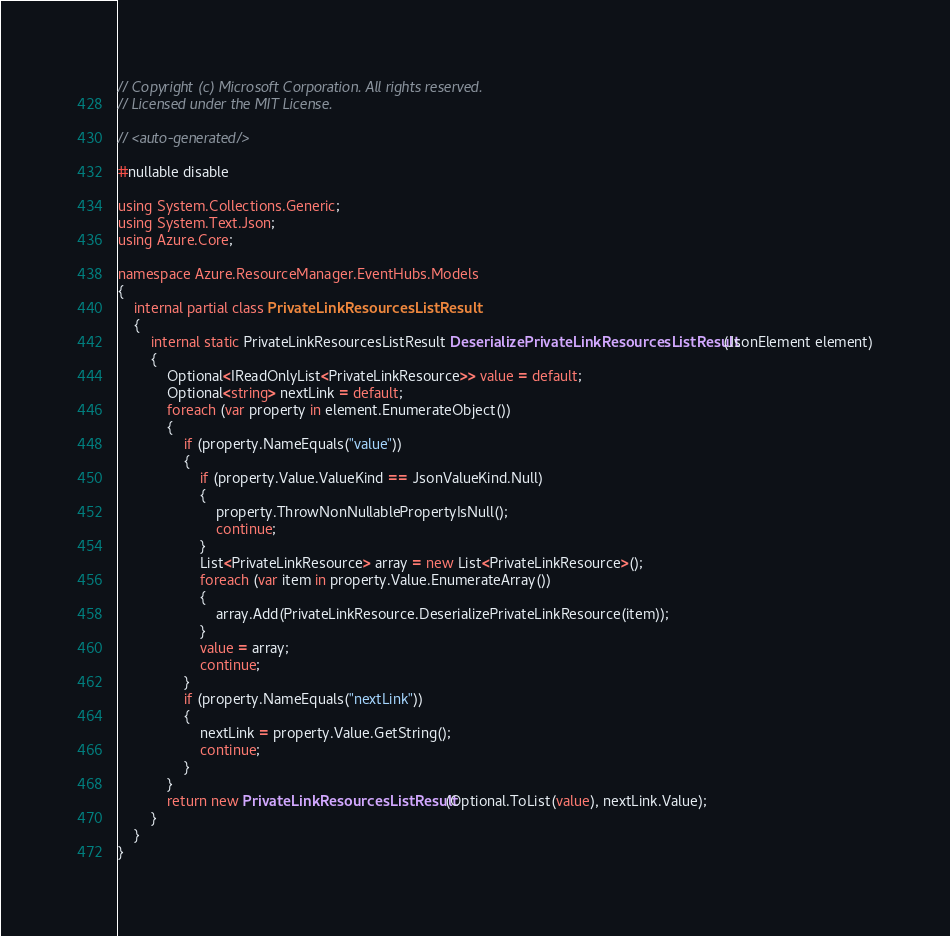Convert code to text. <code><loc_0><loc_0><loc_500><loc_500><_C#_>// Copyright (c) Microsoft Corporation. All rights reserved.
// Licensed under the MIT License.

// <auto-generated/>

#nullable disable

using System.Collections.Generic;
using System.Text.Json;
using Azure.Core;

namespace Azure.ResourceManager.EventHubs.Models
{
    internal partial class PrivateLinkResourcesListResult
    {
        internal static PrivateLinkResourcesListResult DeserializePrivateLinkResourcesListResult(JsonElement element)
        {
            Optional<IReadOnlyList<PrivateLinkResource>> value = default;
            Optional<string> nextLink = default;
            foreach (var property in element.EnumerateObject())
            {
                if (property.NameEquals("value"))
                {
                    if (property.Value.ValueKind == JsonValueKind.Null)
                    {
                        property.ThrowNonNullablePropertyIsNull();
                        continue;
                    }
                    List<PrivateLinkResource> array = new List<PrivateLinkResource>();
                    foreach (var item in property.Value.EnumerateArray())
                    {
                        array.Add(PrivateLinkResource.DeserializePrivateLinkResource(item));
                    }
                    value = array;
                    continue;
                }
                if (property.NameEquals("nextLink"))
                {
                    nextLink = property.Value.GetString();
                    continue;
                }
            }
            return new PrivateLinkResourcesListResult(Optional.ToList(value), nextLink.Value);
        }
    }
}
</code> 